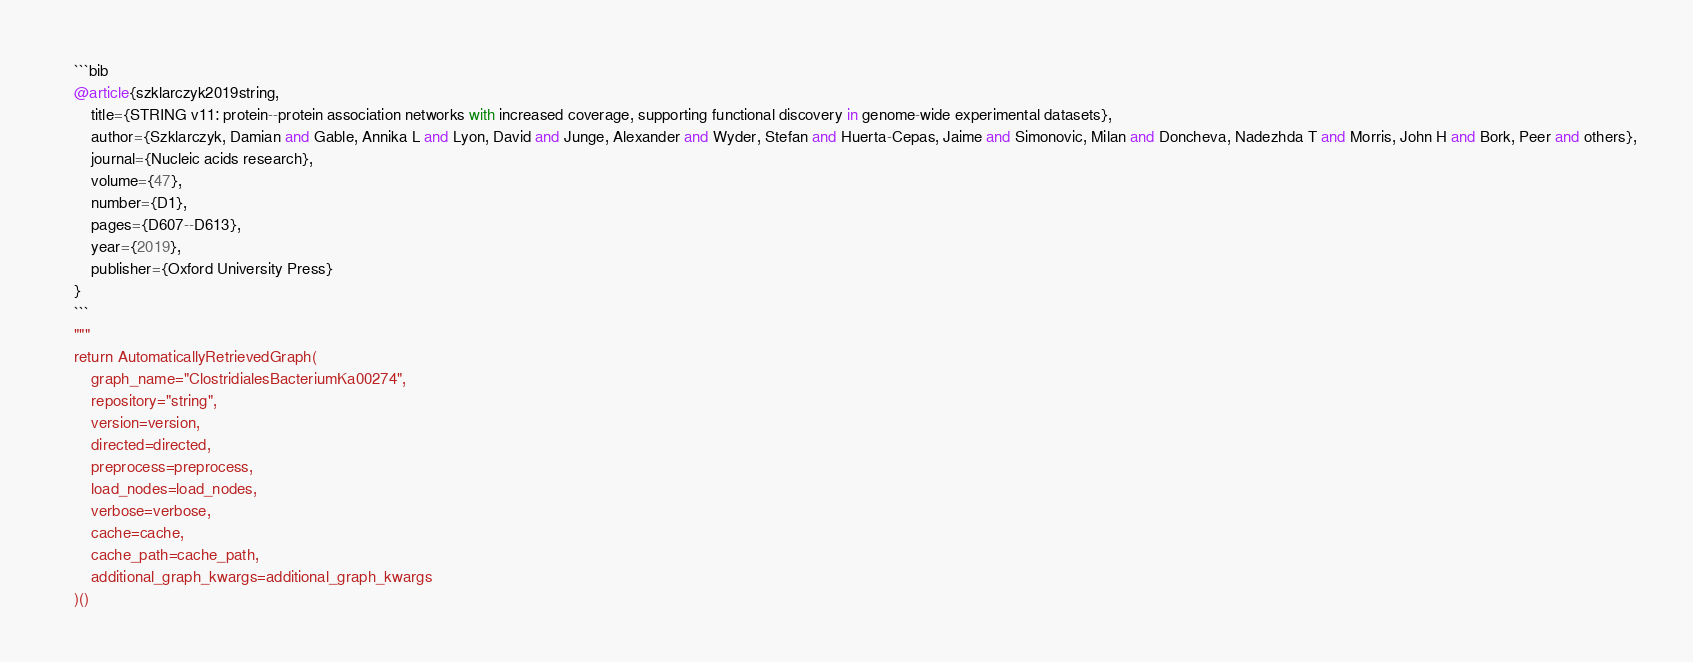Convert code to text. <code><loc_0><loc_0><loc_500><loc_500><_Python_>	```bib
	@article{szklarczyk2019string,
	    title={STRING v11: protein--protein association networks with increased coverage, supporting functional discovery in genome-wide experimental datasets},
	    author={Szklarczyk, Damian and Gable, Annika L and Lyon, David and Junge, Alexander and Wyder, Stefan and Huerta-Cepas, Jaime and Simonovic, Milan and Doncheva, Nadezhda T and Morris, John H and Bork, Peer and others},
	    journal={Nucleic acids research},
	    volume={47},
	    number={D1},
	    pages={D607--D613},
	    year={2019},
	    publisher={Oxford University Press}
	}
	```
    """
    return AutomaticallyRetrievedGraph(
        graph_name="ClostridialesBacteriumKa00274",
        repository="string",
        version=version,
        directed=directed,
        preprocess=preprocess,
        load_nodes=load_nodes,
        verbose=verbose,
        cache=cache,
        cache_path=cache_path,
        additional_graph_kwargs=additional_graph_kwargs
    )()
</code> 